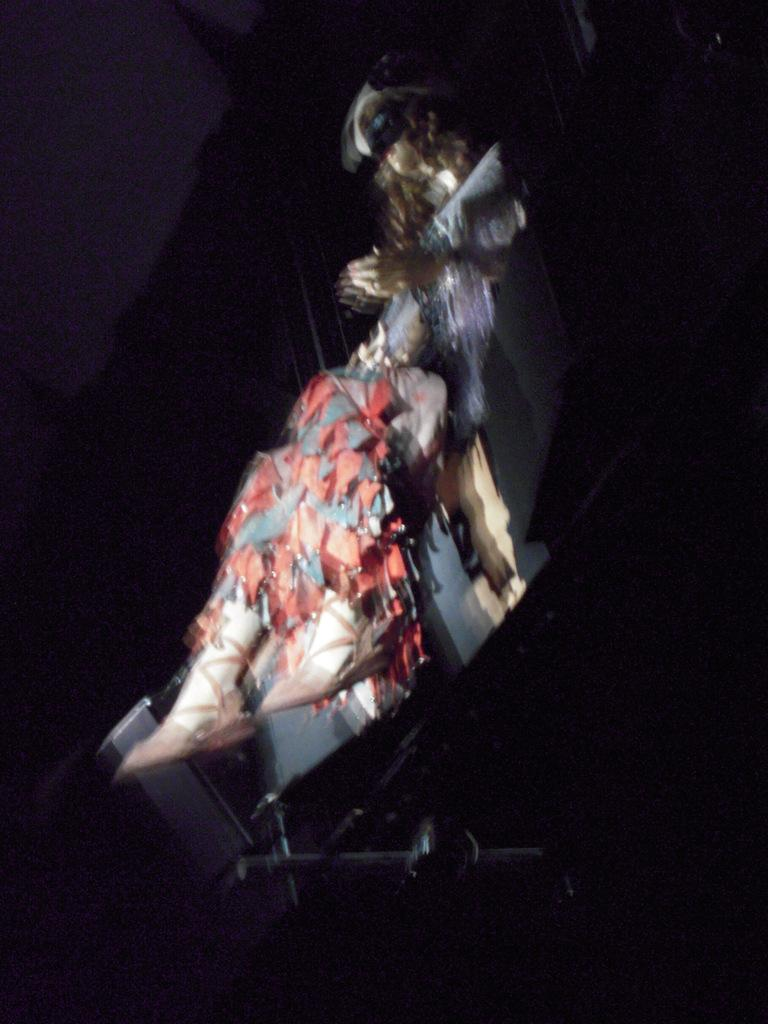What is the main subject of the image? There is a mannequin in the image. What colors is the mannequin wearing? The mannequin is wearing red and grey color cloth. What is the mannequin sitting on? The mannequin is sitting on an object. What color is the background of the image? The background of the image is black. What type of copper dish is the mannequin holding in the image? There is no copper dish present in the image. What meal is being prepared by the mannequin in the image? The mannequin is not preparing a meal in the image; it is a stationary object. --- Facts: 1. There is a car in the image. 2. The car is parked on the street. 3. The car is red. 4. There are trees in the background of the image. 5. The sky is visible in the image. Absurd Topics: parrot, sand, dance Conversation: What is the main subject of the image? There is a car in the image. Where is the car located? The car is parked on the street. What color is the car? The car is red. What can be seen in the background of the image? There are trees in the background of the image. What is visible above the trees in the image? The sky is visible in the image. Reasoning: Let's think step by step in order to produce the conversation. We start by identifying the main subject of the image, which is the car. Then, we describe the car's location, noting that it is parked on the street. Next, we mention the car's color, which is red. Finally, we describe the background and the sky visible above the trees. Absurd Question/Answer: Can you tell me how many parrots are sitting on the car in the image? There are no parrots present in the image. What type of dance is being performed by the car in the image? The car is not performing a dance in the image; it is a stationary object. 